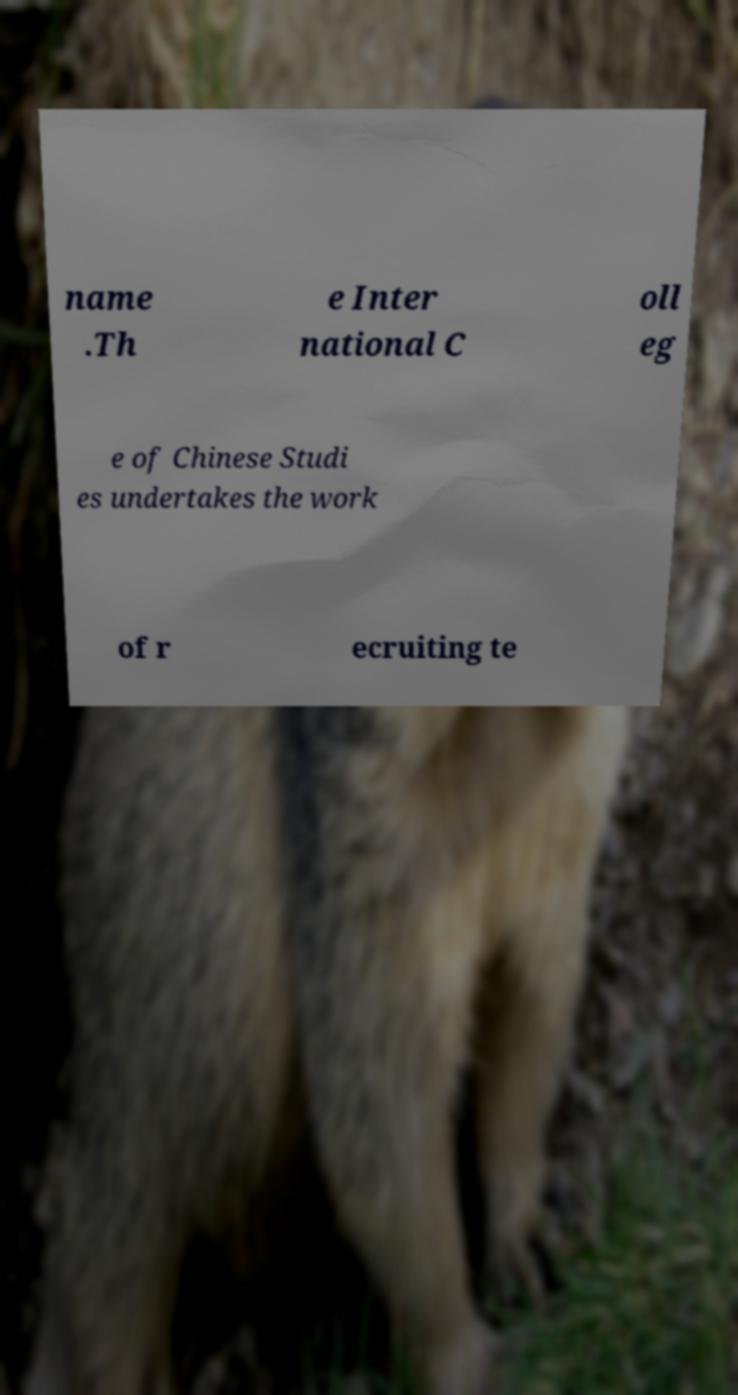Can you accurately transcribe the text from the provided image for me? name .Th e Inter national C oll eg e of Chinese Studi es undertakes the work of r ecruiting te 